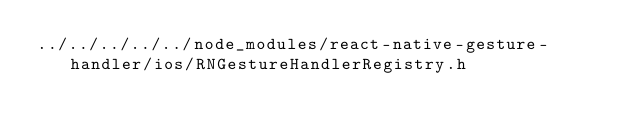<code> <loc_0><loc_0><loc_500><loc_500><_C_>../../../../../node_modules/react-native-gesture-handler/ios/RNGestureHandlerRegistry.h</code> 